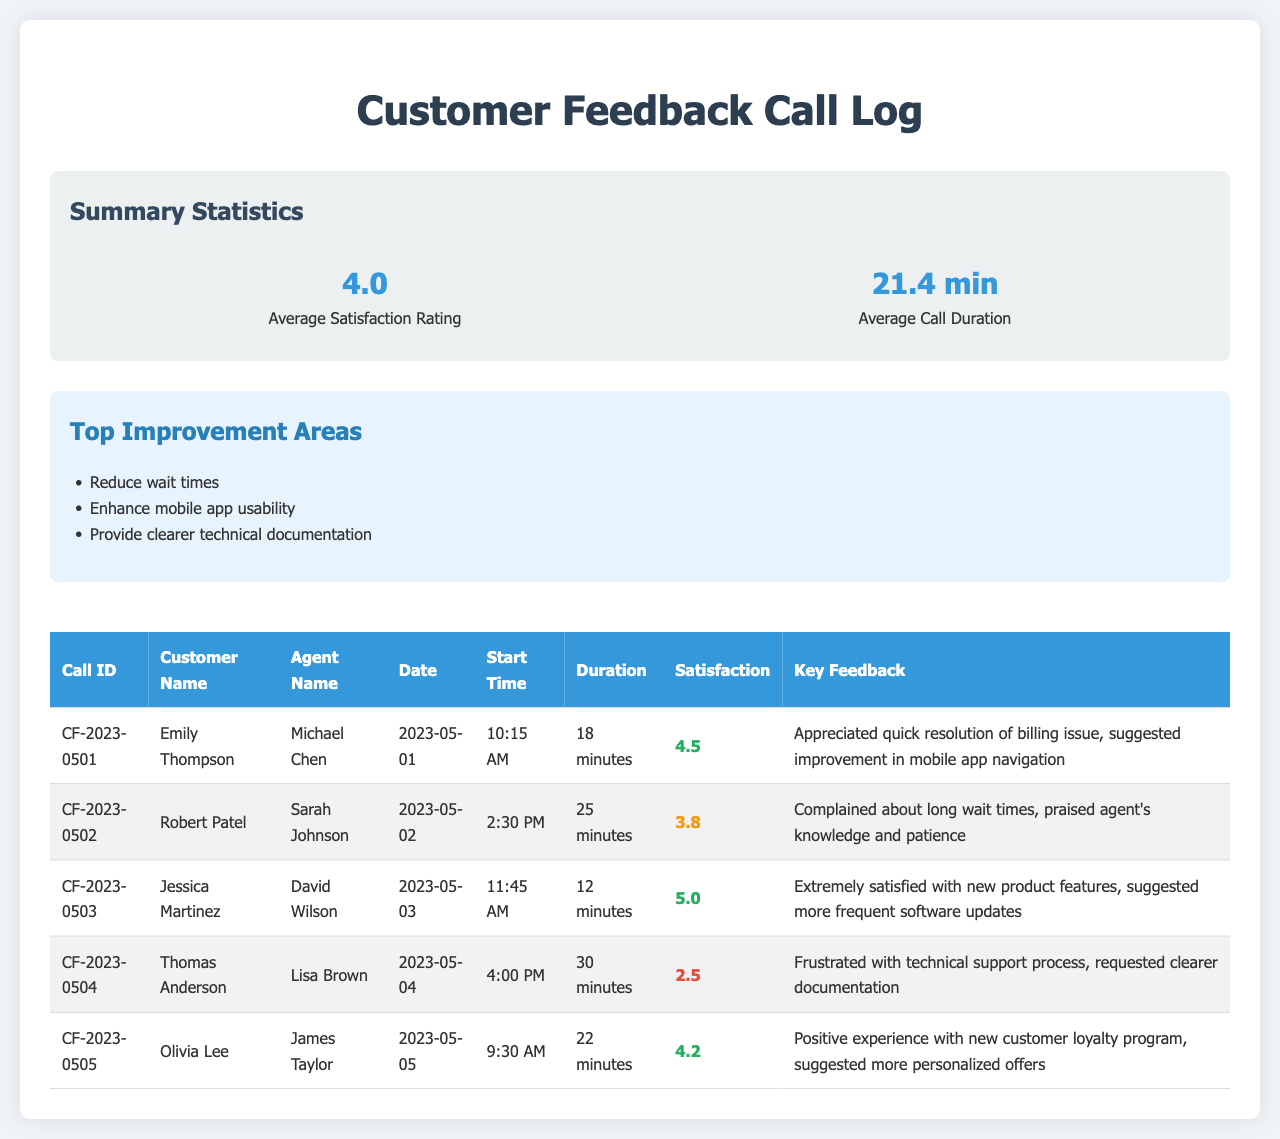What is the average satisfaction rating? The average satisfaction rating is provided in the summary statistics, which is 4.0.
Answer: 4.0 Who had the highest satisfaction rating? The highest satisfaction rating can be found in the call log; Jessica Martinez received a rating of 5.0.
Answer: Jessica Martinez What was the duration of the call with Thomas Anderson? The call duration for Thomas Anderson in the call log is listed as 30 minutes.
Answer: 30 minutes What feedback did Emily Thompson provide? Emily Thompson's key feedback is mentioned in the call log, where she appreciated the quick resolution of a billing issue and suggested improvement in mobile app navigation.
Answer: Appreciated quick resolution of billing issue, suggested improvement in mobile app navigation Which area requires improvement according to the summary? The summary lists several improvement areas, and one is to reduce wait times.
Answer: Reduce wait times What date did the call with Robert Patel occur? The date of the call with Robert Patel can be found in the call log, which is 2023-05-02.
Answer: 2023-05-02 What was the feedback from Olivia Lee? Olivia Lee's feedback in the call log indicated a positive experience with the new customer loyalty program and suggested more personalized offers.
Answer: Positive experience with new customer loyalty program, suggested more personalized offers How many minutes was the average call duration? The average call duration is provided in the summary statistics, which is 21.4 minutes.
Answer: 21.4 min 